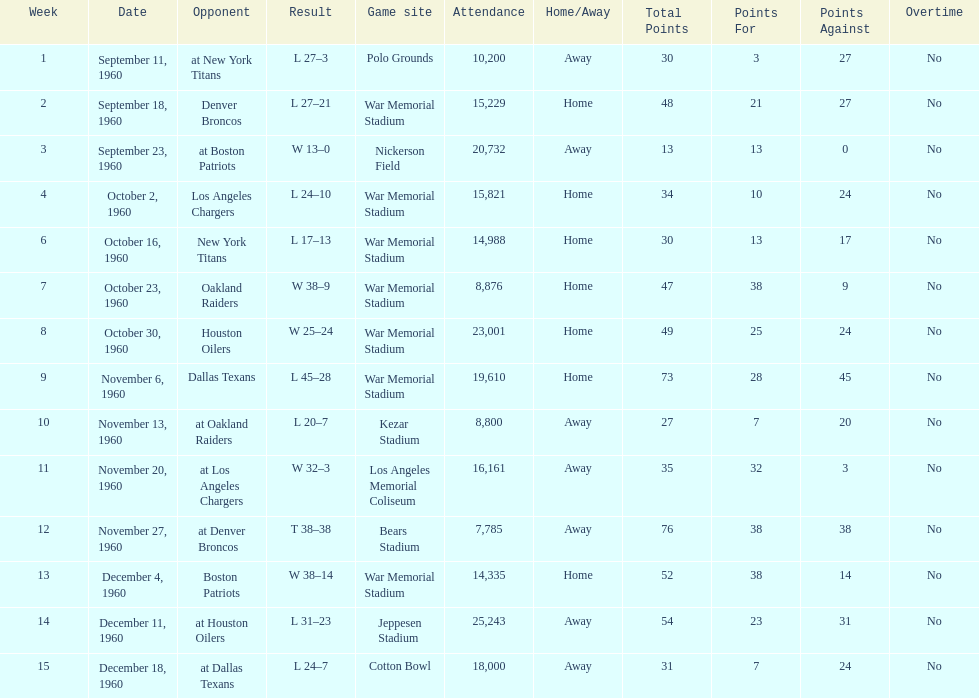Who did the bills play after the oakland raiders? Houston Oilers. 